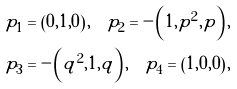Convert formula to latex. <formula><loc_0><loc_0><loc_500><loc_500>p _ { 1 } & = \left ( 0 , 1 , 0 \right ) , \quad p _ { 2 } = - \left ( 1 , p ^ { 2 } , p \right ) , \\ p _ { 3 } & = - \left ( q ^ { 2 } , 1 , q \right ) , \quad p _ { 4 } = \left ( 1 , 0 , 0 \right ) ,</formula> 